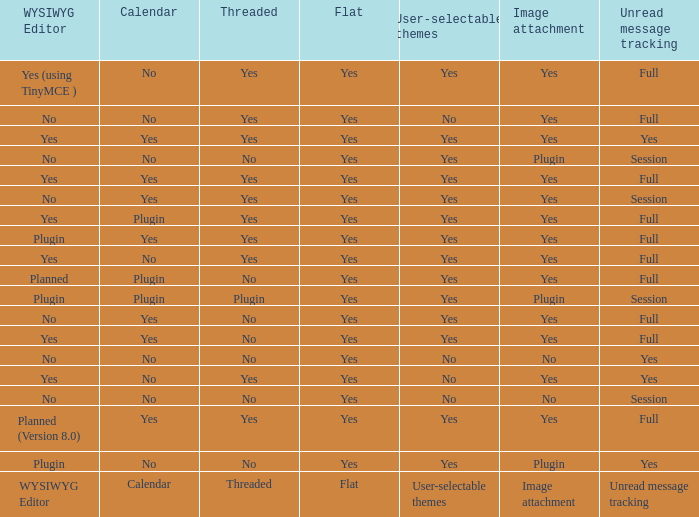Which Calendar has a WYSIWYG Editor of no, and an Unread message tracking of session, and an Image attachment of no? No. 